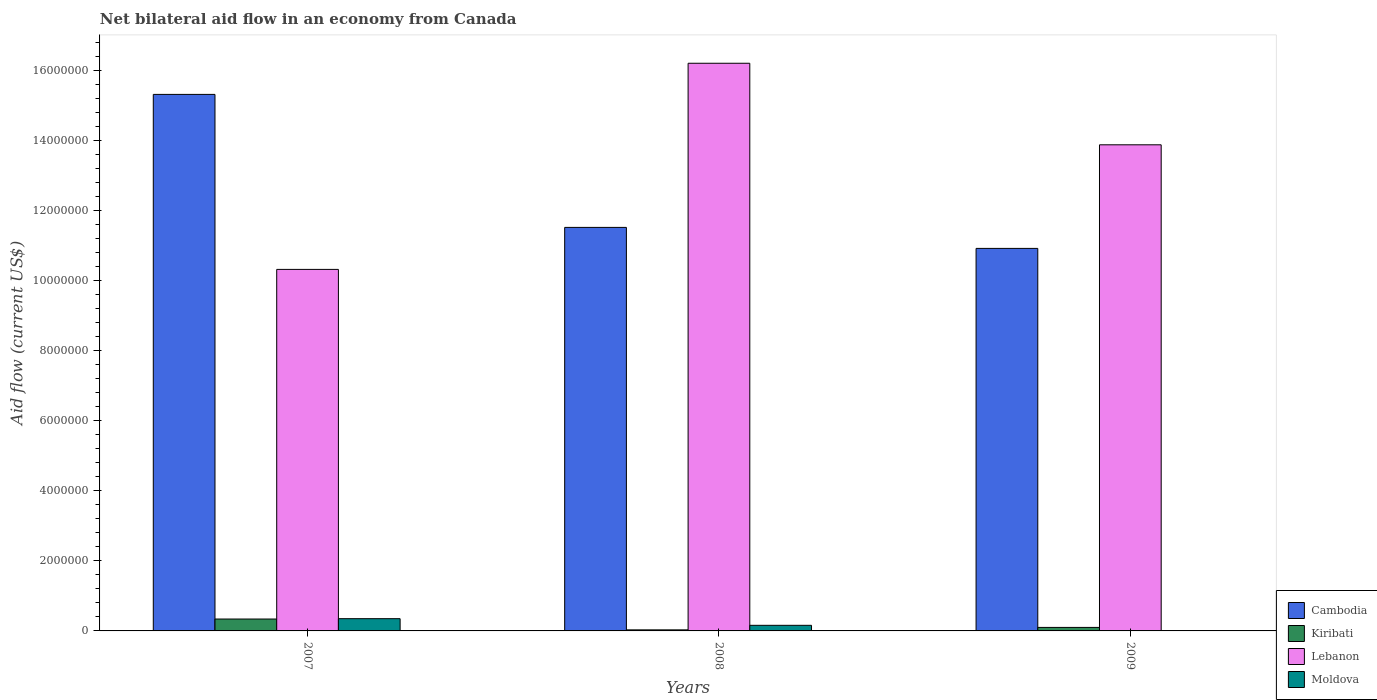Are the number of bars on each tick of the X-axis equal?
Provide a short and direct response. Yes. How many bars are there on the 1st tick from the left?
Provide a succinct answer. 4. How many bars are there on the 1st tick from the right?
Provide a short and direct response. 4. What is the net bilateral aid flow in Lebanon in 2009?
Provide a succinct answer. 1.39e+07. Across all years, what is the maximum net bilateral aid flow in Cambodia?
Your answer should be compact. 1.53e+07. Across all years, what is the minimum net bilateral aid flow in Cambodia?
Give a very brief answer. 1.09e+07. In which year was the net bilateral aid flow in Cambodia minimum?
Provide a short and direct response. 2009. What is the total net bilateral aid flow in Moldova in the graph?
Ensure brevity in your answer.  5.20e+05. What is the difference between the net bilateral aid flow in Lebanon in 2007 and that in 2008?
Your response must be concise. -5.89e+06. What is the difference between the net bilateral aid flow in Moldova in 2007 and the net bilateral aid flow in Kiribati in 2009?
Provide a short and direct response. 2.50e+05. What is the average net bilateral aid flow in Cambodia per year?
Your answer should be compact. 1.26e+07. In the year 2008, what is the difference between the net bilateral aid flow in Lebanon and net bilateral aid flow in Moldova?
Offer a terse response. 1.61e+07. In how many years, is the net bilateral aid flow in Lebanon greater than 7600000 US$?
Give a very brief answer. 3. What is the ratio of the net bilateral aid flow in Moldova in 2007 to that in 2008?
Give a very brief answer. 2.19. Is the net bilateral aid flow in Lebanon in 2008 less than that in 2009?
Your response must be concise. No. Is the difference between the net bilateral aid flow in Lebanon in 2007 and 2009 greater than the difference between the net bilateral aid flow in Moldova in 2007 and 2009?
Make the answer very short. No. What is the difference between the highest and the second highest net bilateral aid flow in Cambodia?
Your response must be concise. 3.80e+06. What is the difference between the highest and the lowest net bilateral aid flow in Lebanon?
Offer a very short reply. 5.89e+06. What does the 3rd bar from the left in 2007 represents?
Your answer should be compact. Lebanon. What does the 3rd bar from the right in 2009 represents?
Your response must be concise. Kiribati. What is the difference between two consecutive major ticks on the Y-axis?
Your response must be concise. 2.00e+06. Does the graph contain grids?
Provide a succinct answer. No. What is the title of the graph?
Your response must be concise. Net bilateral aid flow in an economy from Canada. What is the label or title of the Y-axis?
Offer a very short reply. Aid flow (current US$). What is the Aid flow (current US$) of Cambodia in 2007?
Offer a very short reply. 1.53e+07. What is the Aid flow (current US$) in Lebanon in 2007?
Keep it short and to the point. 1.03e+07. What is the Aid flow (current US$) of Cambodia in 2008?
Provide a succinct answer. 1.15e+07. What is the Aid flow (current US$) in Lebanon in 2008?
Your answer should be compact. 1.62e+07. What is the Aid flow (current US$) of Moldova in 2008?
Make the answer very short. 1.60e+05. What is the Aid flow (current US$) of Cambodia in 2009?
Offer a terse response. 1.09e+07. What is the Aid flow (current US$) in Lebanon in 2009?
Give a very brief answer. 1.39e+07. Across all years, what is the maximum Aid flow (current US$) of Cambodia?
Provide a short and direct response. 1.53e+07. Across all years, what is the maximum Aid flow (current US$) of Kiribati?
Your response must be concise. 3.40e+05. Across all years, what is the maximum Aid flow (current US$) of Lebanon?
Provide a short and direct response. 1.62e+07. Across all years, what is the maximum Aid flow (current US$) in Moldova?
Ensure brevity in your answer.  3.50e+05. Across all years, what is the minimum Aid flow (current US$) in Cambodia?
Provide a short and direct response. 1.09e+07. Across all years, what is the minimum Aid flow (current US$) in Lebanon?
Keep it short and to the point. 1.03e+07. Across all years, what is the minimum Aid flow (current US$) in Moldova?
Ensure brevity in your answer.  10000. What is the total Aid flow (current US$) in Cambodia in the graph?
Make the answer very short. 3.78e+07. What is the total Aid flow (current US$) of Kiribati in the graph?
Your answer should be compact. 4.70e+05. What is the total Aid flow (current US$) of Lebanon in the graph?
Your answer should be very brief. 4.04e+07. What is the total Aid flow (current US$) of Moldova in the graph?
Keep it short and to the point. 5.20e+05. What is the difference between the Aid flow (current US$) in Cambodia in 2007 and that in 2008?
Offer a terse response. 3.80e+06. What is the difference between the Aid flow (current US$) in Lebanon in 2007 and that in 2008?
Ensure brevity in your answer.  -5.89e+06. What is the difference between the Aid flow (current US$) of Cambodia in 2007 and that in 2009?
Offer a very short reply. 4.40e+06. What is the difference between the Aid flow (current US$) of Kiribati in 2007 and that in 2009?
Provide a succinct answer. 2.40e+05. What is the difference between the Aid flow (current US$) of Lebanon in 2007 and that in 2009?
Your answer should be compact. -3.56e+06. What is the difference between the Aid flow (current US$) in Cambodia in 2008 and that in 2009?
Offer a very short reply. 6.00e+05. What is the difference between the Aid flow (current US$) in Lebanon in 2008 and that in 2009?
Offer a very short reply. 2.33e+06. What is the difference between the Aid flow (current US$) of Cambodia in 2007 and the Aid flow (current US$) of Kiribati in 2008?
Provide a short and direct response. 1.53e+07. What is the difference between the Aid flow (current US$) of Cambodia in 2007 and the Aid flow (current US$) of Lebanon in 2008?
Offer a terse response. -8.90e+05. What is the difference between the Aid flow (current US$) in Cambodia in 2007 and the Aid flow (current US$) in Moldova in 2008?
Provide a short and direct response. 1.52e+07. What is the difference between the Aid flow (current US$) in Kiribati in 2007 and the Aid flow (current US$) in Lebanon in 2008?
Ensure brevity in your answer.  -1.59e+07. What is the difference between the Aid flow (current US$) in Lebanon in 2007 and the Aid flow (current US$) in Moldova in 2008?
Your response must be concise. 1.02e+07. What is the difference between the Aid flow (current US$) of Cambodia in 2007 and the Aid flow (current US$) of Kiribati in 2009?
Give a very brief answer. 1.52e+07. What is the difference between the Aid flow (current US$) of Cambodia in 2007 and the Aid flow (current US$) of Lebanon in 2009?
Ensure brevity in your answer.  1.44e+06. What is the difference between the Aid flow (current US$) in Cambodia in 2007 and the Aid flow (current US$) in Moldova in 2009?
Offer a terse response. 1.53e+07. What is the difference between the Aid flow (current US$) in Kiribati in 2007 and the Aid flow (current US$) in Lebanon in 2009?
Keep it short and to the point. -1.36e+07. What is the difference between the Aid flow (current US$) in Lebanon in 2007 and the Aid flow (current US$) in Moldova in 2009?
Make the answer very short. 1.03e+07. What is the difference between the Aid flow (current US$) of Cambodia in 2008 and the Aid flow (current US$) of Kiribati in 2009?
Make the answer very short. 1.14e+07. What is the difference between the Aid flow (current US$) of Cambodia in 2008 and the Aid flow (current US$) of Lebanon in 2009?
Provide a succinct answer. -2.36e+06. What is the difference between the Aid flow (current US$) in Cambodia in 2008 and the Aid flow (current US$) in Moldova in 2009?
Your answer should be compact. 1.15e+07. What is the difference between the Aid flow (current US$) in Kiribati in 2008 and the Aid flow (current US$) in Lebanon in 2009?
Make the answer very short. -1.39e+07. What is the difference between the Aid flow (current US$) of Kiribati in 2008 and the Aid flow (current US$) of Moldova in 2009?
Offer a terse response. 2.00e+04. What is the difference between the Aid flow (current US$) in Lebanon in 2008 and the Aid flow (current US$) in Moldova in 2009?
Your response must be concise. 1.62e+07. What is the average Aid flow (current US$) of Cambodia per year?
Provide a short and direct response. 1.26e+07. What is the average Aid flow (current US$) of Kiribati per year?
Your answer should be compact. 1.57e+05. What is the average Aid flow (current US$) of Lebanon per year?
Your response must be concise. 1.35e+07. What is the average Aid flow (current US$) in Moldova per year?
Provide a short and direct response. 1.73e+05. In the year 2007, what is the difference between the Aid flow (current US$) in Cambodia and Aid flow (current US$) in Kiribati?
Offer a very short reply. 1.50e+07. In the year 2007, what is the difference between the Aid flow (current US$) in Cambodia and Aid flow (current US$) in Moldova?
Provide a short and direct response. 1.50e+07. In the year 2007, what is the difference between the Aid flow (current US$) of Kiribati and Aid flow (current US$) of Lebanon?
Offer a terse response. -9.99e+06. In the year 2007, what is the difference between the Aid flow (current US$) in Lebanon and Aid flow (current US$) in Moldova?
Make the answer very short. 9.98e+06. In the year 2008, what is the difference between the Aid flow (current US$) in Cambodia and Aid flow (current US$) in Kiribati?
Offer a very short reply. 1.15e+07. In the year 2008, what is the difference between the Aid flow (current US$) in Cambodia and Aid flow (current US$) in Lebanon?
Make the answer very short. -4.69e+06. In the year 2008, what is the difference between the Aid flow (current US$) of Cambodia and Aid flow (current US$) of Moldova?
Provide a short and direct response. 1.14e+07. In the year 2008, what is the difference between the Aid flow (current US$) of Kiribati and Aid flow (current US$) of Lebanon?
Offer a very short reply. -1.62e+07. In the year 2008, what is the difference between the Aid flow (current US$) in Lebanon and Aid flow (current US$) in Moldova?
Your answer should be compact. 1.61e+07. In the year 2009, what is the difference between the Aid flow (current US$) in Cambodia and Aid flow (current US$) in Kiribati?
Your answer should be very brief. 1.08e+07. In the year 2009, what is the difference between the Aid flow (current US$) of Cambodia and Aid flow (current US$) of Lebanon?
Ensure brevity in your answer.  -2.96e+06. In the year 2009, what is the difference between the Aid flow (current US$) in Cambodia and Aid flow (current US$) in Moldova?
Keep it short and to the point. 1.09e+07. In the year 2009, what is the difference between the Aid flow (current US$) of Kiribati and Aid flow (current US$) of Lebanon?
Provide a short and direct response. -1.38e+07. In the year 2009, what is the difference between the Aid flow (current US$) in Kiribati and Aid flow (current US$) in Moldova?
Your response must be concise. 9.00e+04. In the year 2009, what is the difference between the Aid flow (current US$) of Lebanon and Aid flow (current US$) of Moldova?
Make the answer very short. 1.39e+07. What is the ratio of the Aid flow (current US$) in Cambodia in 2007 to that in 2008?
Your response must be concise. 1.33. What is the ratio of the Aid flow (current US$) of Kiribati in 2007 to that in 2008?
Your answer should be very brief. 11.33. What is the ratio of the Aid flow (current US$) in Lebanon in 2007 to that in 2008?
Your answer should be very brief. 0.64. What is the ratio of the Aid flow (current US$) of Moldova in 2007 to that in 2008?
Make the answer very short. 2.19. What is the ratio of the Aid flow (current US$) in Cambodia in 2007 to that in 2009?
Keep it short and to the point. 1.4. What is the ratio of the Aid flow (current US$) of Kiribati in 2007 to that in 2009?
Make the answer very short. 3.4. What is the ratio of the Aid flow (current US$) in Lebanon in 2007 to that in 2009?
Provide a succinct answer. 0.74. What is the ratio of the Aid flow (current US$) in Moldova in 2007 to that in 2009?
Make the answer very short. 35. What is the ratio of the Aid flow (current US$) of Cambodia in 2008 to that in 2009?
Offer a very short reply. 1.05. What is the ratio of the Aid flow (current US$) of Lebanon in 2008 to that in 2009?
Keep it short and to the point. 1.17. What is the ratio of the Aid flow (current US$) of Moldova in 2008 to that in 2009?
Make the answer very short. 16. What is the difference between the highest and the second highest Aid flow (current US$) in Cambodia?
Keep it short and to the point. 3.80e+06. What is the difference between the highest and the second highest Aid flow (current US$) in Lebanon?
Provide a short and direct response. 2.33e+06. What is the difference between the highest and the second highest Aid flow (current US$) of Moldova?
Keep it short and to the point. 1.90e+05. What is the difference between the highest and the lowest Aid flow (current US$) in Cambodia?
Your answer should be compact. 4.40e+06. What is the difference between the highest and the lowest Aid flow (current US$) of Lebanon?
Provide a short and direct response. 5.89e+06. What is the difference between the highest and the lowest Aid flow (current US$) in Moldova?
Your answer should be compact. 3.40e+05. 